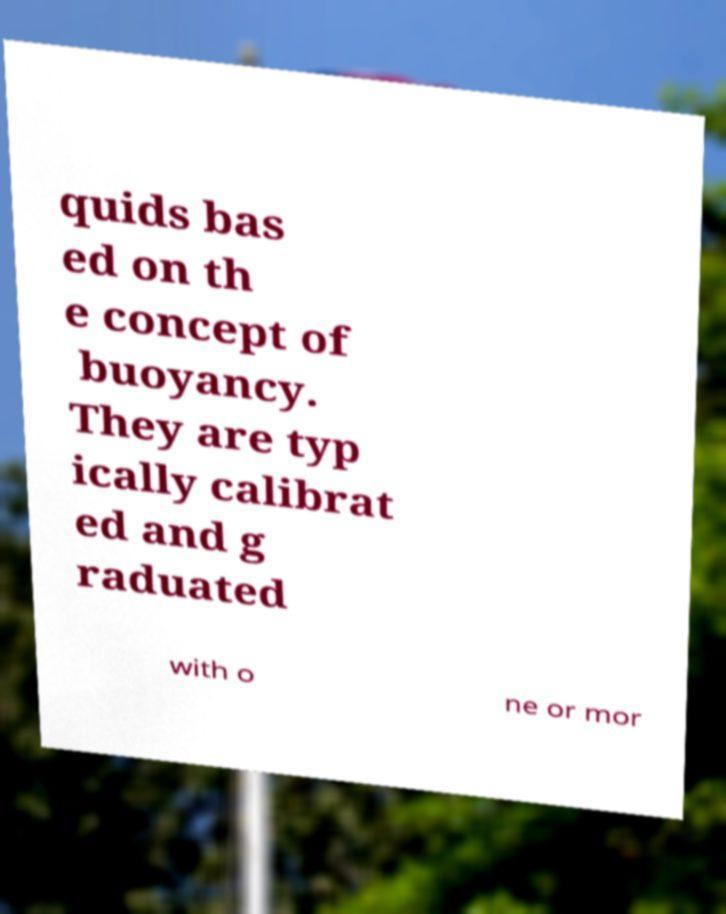Could you extract and type out the text from this image? quids bas ed on th e concept of buoyancy. They are typ ically calibrat ed and g raduated with o ne or mor 